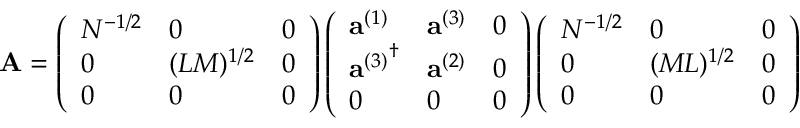Convert formula to latex. <formula><loc_0><loc_0><loc_500><loc_500>{ A } = \left ( \begin{array} { l l l } { { N ^ { - 1 / 2 } } } & { 0 } & { 0 } \\ { 0 } & { { ( L M ) ^ { 1 / 2 } } } & { 0 } \\ { 0 } & { 0 } & { 0 } \end{array} \right ) \left ( \begin{array} { l l l } { { { a } ^ { ( 1 ) } } } & { { { a } ^ { ( 3 ) } } } & { 0 } \\ { { { { a } ^ { ( 3 ) } } ^ { \dagger } } } & { { { a } ^ { ( 2 ) } } } & { 0 } \\ { 0 } & { 0 } & { 0 } \end{array} \right ) \left ( \begin{array} { l l l } { { N ^ { - 1 / 2 } } } & { 0 } & { 0 } \\ { 0 } & { { ( M L ) ^ { 1 / 2 } } } & { 0 } \\ { 0 } & { 0 } & { 0 } \end{array} \right )</formula> 